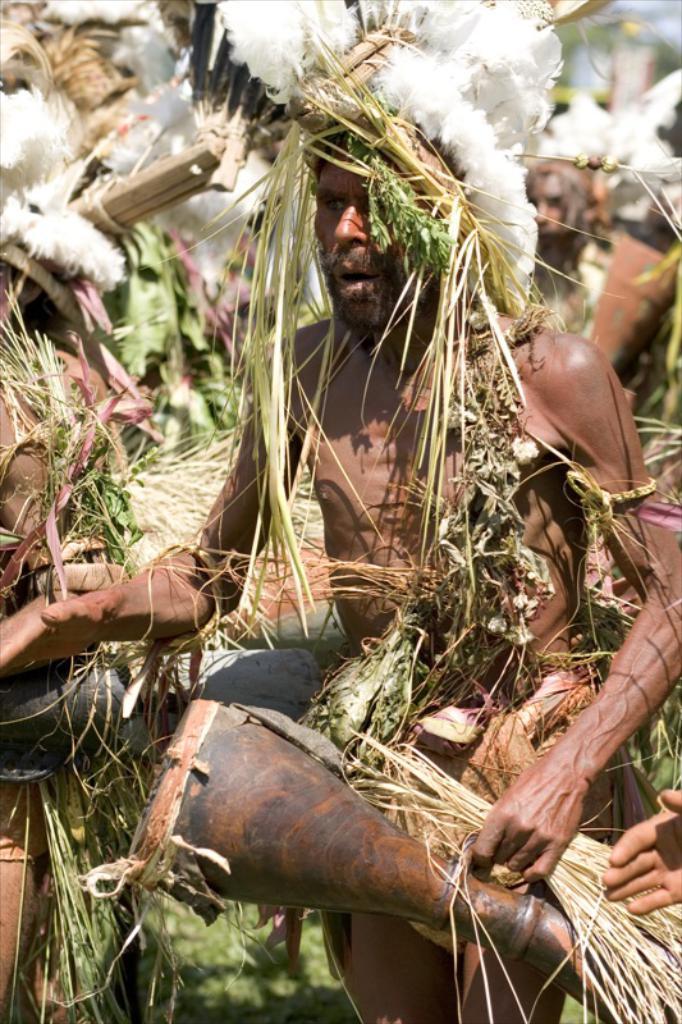In one or two sentences, can you explain what this image depicts? In this image, we can see people wearing costumes. 